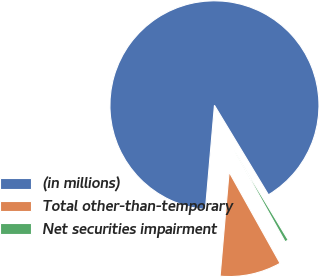Convert chart to OTSL. <chart><loc_0><loc_0><loc_500><loc_500><pie_chart><fcel>(in millions)<fcel>Total other-than-temporary<fcel>Net securities impairment<nl><fcel>89.98%<fcel>9.48%<fcel>0.54%<nl></chart> 